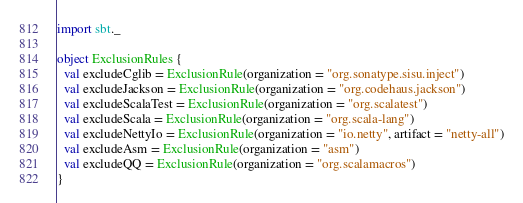<code> <loc_0><loc_0><loc_500><loc_500><_Scala_>import sbt._

object ExclusionRules {
  val excludeCglib = ExclusionRule(organization = "org.sonatype.sisu.inject")
  val excludeJackson = ExclusionRule(organization = "org.codehaus.jackson")
  val excludeScalaTest = ExclusionRule(organization = "org.scalatest")
  val excludeScala = ExclusionRule(organization = "org.scala-lang")
  val excludeNettyIo = ExclusionRule(organization = "io.netty", artifact = "netty-all")
  val excludeAsm = ExclusionRule(organization = "asm")
  val excludeQQ = ExclusionRule(organization = "org.scalamacros")
}</code> 